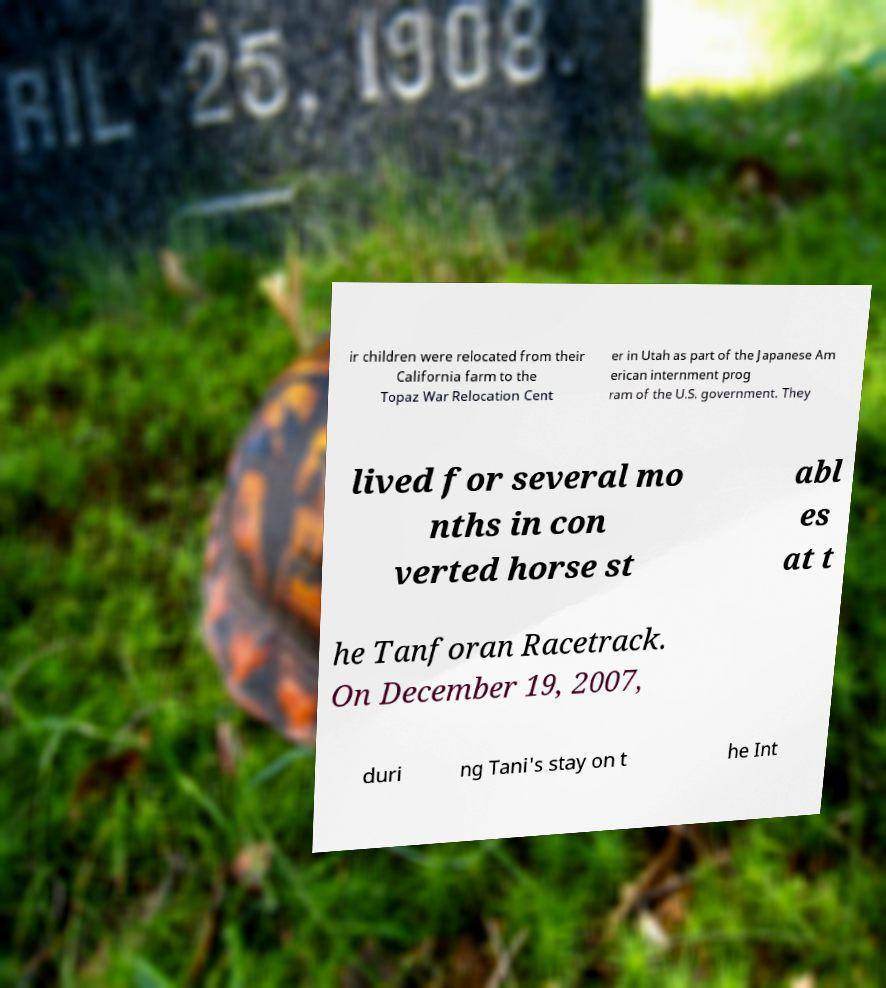I need the written content from this picture converted into text. Can you do that? ir children were relocated from their California farm to the Topaz War Relocation Cent er in Utah as part of the Japanese Am erican internment prog ram of the U.S. government. They lived for several mo nths in con verted horse st abl es at t he Tanforan Racetrack. On December 19, 2007, duri ng Tani's stay on t he Int 